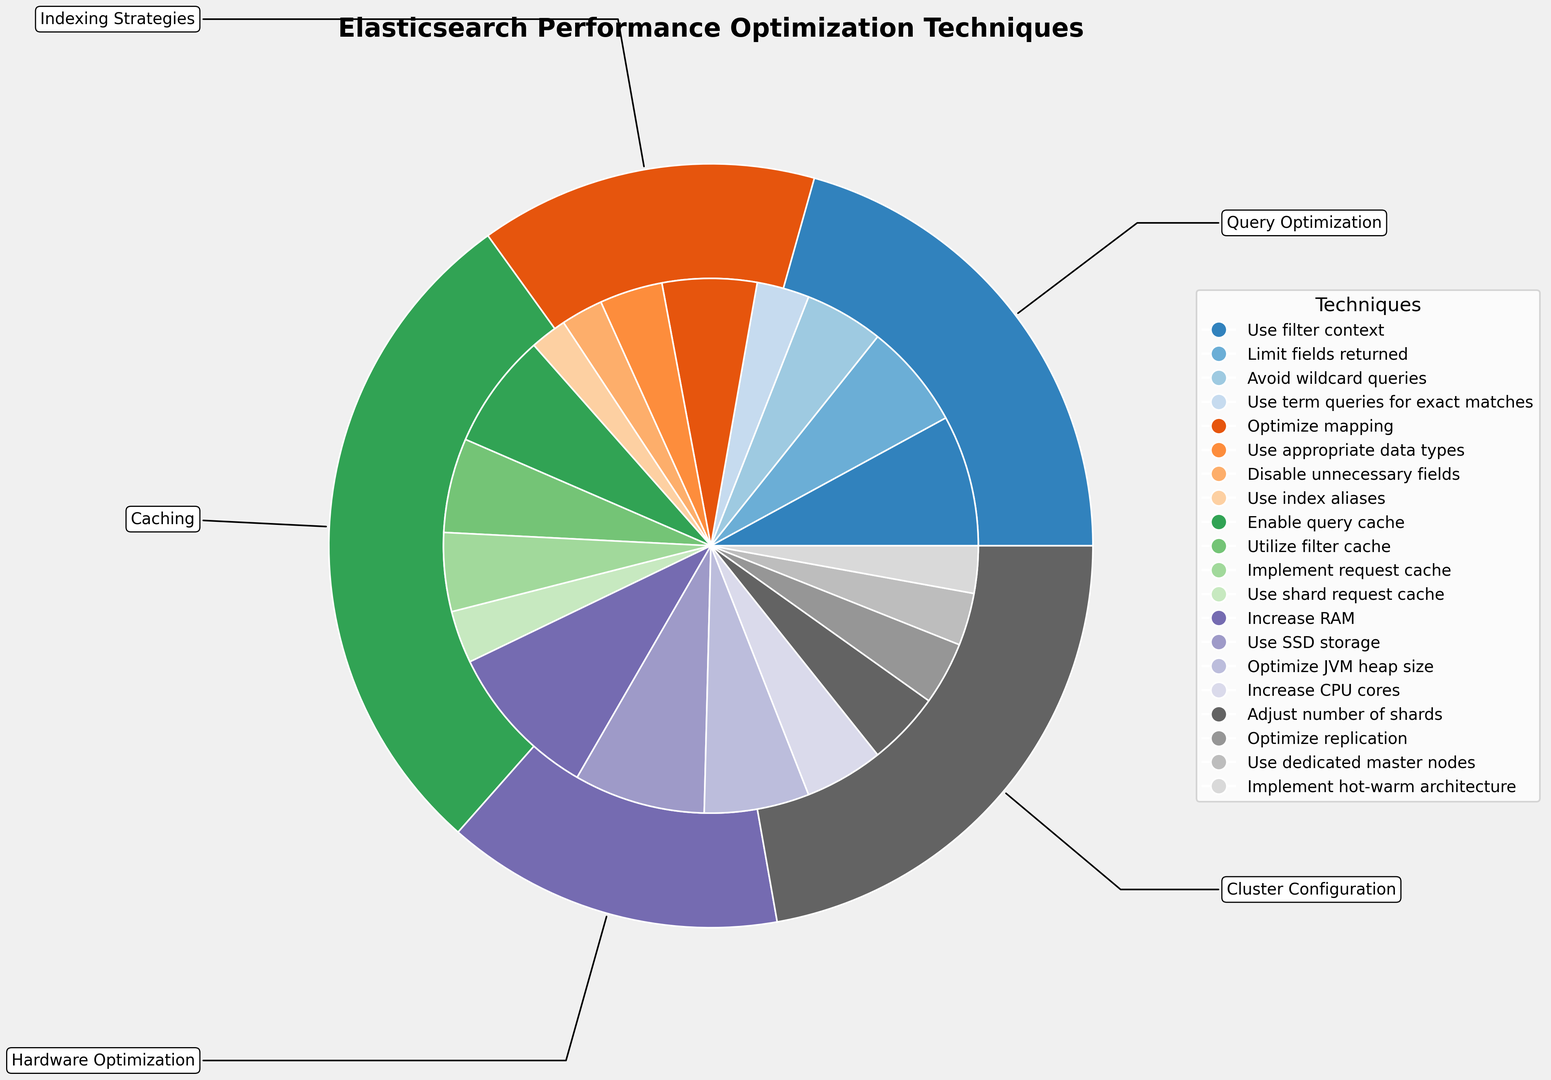What category has the highest combined impact on response time? Look at the outer ring of the pie chart and identify the segment with the largest size. The "Query Optimization" category appears largest.
Answer: Query Optimization Which technique within the "Hardware Optimization" category has the highest impact on response time? Focus on the inner ring segments that fall within the "Hardware Optimization" category. Notice that "Increase RAM" has the largest segment.
Answer: Increase RAM What is the combined impact on response time of "Caching" techniques? Sum the inner segments within the "Caching" outer segment: 22 (Enable query cache) + 18 (Utilize filter cache) + 15 (Implement request cache) + 10 (Use shard request cache) = 65.
Answer: 65 Compare the impact of "Use filter context" versus "Optimize JVM heap size". Which one has a greater impact? Look at these specific segments in the inner ring. "Use filter context" has an impact of 25, whereas "Optimize JVM heap size" has an impact of 20.
Answer: Use filter context How much more impact does "Increase RAM" have compared to "Use SSD storage"? Find the sizes of these segments in the inner ring. "Increase RAM" has an impact of 30, and "Use SSD storage" has an impact of 25. The difference is 30 - 25 = 5.
Answer: 5 What percentage of the total impact is attributed to the "Query Optimization" category? Calculate the total impact of all categories by summing the outer ring values. Then, sum the impacts within "Query Optimization": 25 + 20 + 15 + 10 = 70. The total combined impact is (25+20+15+10+18+12+8+7+22+18+15+10+30+25+20+15+14+12+10+9) = 305. The percentage is (70/305) * 100 ≈ 22.95%.
Answer: ~23% Which category has the smallest combined impact on response time? Look at the outer ring of the pie chart and identify the segment with the smallest size. The "Cluster Configuration" category appears smallest.
Answer: Cluster Configuration How does the impact of "Adjust number of shards" compare to "Use index aliases"? Find these specific segments in the inner ring. "Adjust number of shards" has an impact of 14, whereas "Use index aliases" has an impact of 7. 14 is greater than 7.
Answer: Adjust number of shards What are the three highest-impact techniques across all categories? Look at the inner ring and identify the three largest segments. These are "Increase RAM" (30), "Use SSD storage" (25), and "Enable query cache" (22).
Answer: Increase RAM, Use SSD storage, Enable query cache How much combined impact do "Query Optimization" and "Hardware Optimization" techniques have on response time? Sum the impacts within each category: Query Optimization (25 + 20 + 15 + 10 = 70) and Hardware Optimization (30 + 25 + 20 + 15 = 90). Combined impact is 70 + 90 = 160.
Answer: 160 